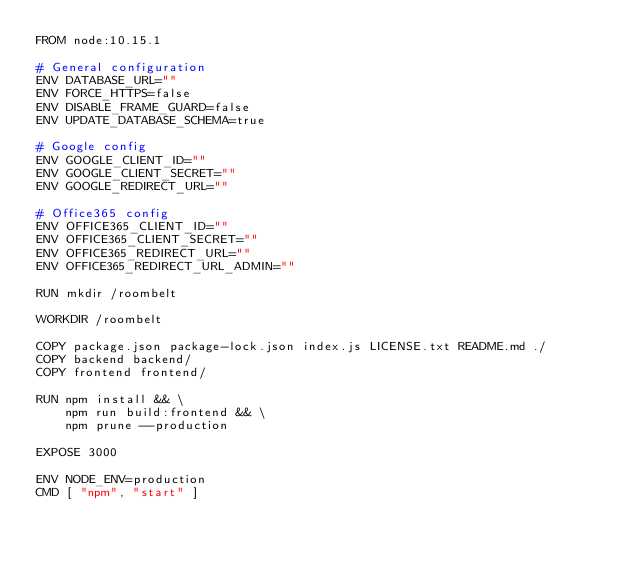<code> <loc_0><loc_0><loc_500><loc_500><_Dockerfile_>FROM node:10.15.1

# General configuration
ENV DATABASE_URL=""
ENV FORCE_HTTPS=false
ENV DISABLE_FRAME_GUARD=false
ENV UPDATE_DATABASE_SCHEMA=true

# Google config
ENV GOOGLE_CLIENT_ID=""
ENV GOOGLE_CLIENT_SECRET=""
ENV GOOGLE_REDIRECT_URL=""

# Office365 config
ENV OFFICE365_CLIENT_ID=""
ENV OFFICE365_CLIENT_SECRET=""
ENV OFFICE365_REDIRECT_URL=""
ENV OFFICE365_REDIRECT_URL_ADMIN=""

RUN mkdir /roombelt

WORKDIR /roombelt

COPY package.json package-lock.json index.js LICENSE.txt README.md ./
COPY backend backend/
COPY frontend frontend/

RUN npm install && \
    npm run build:frontend && \
    npm prune --production

EXPOSE 3000

ENV NODE_ENV=production
CMD [ "npm", "start" ]
</code> 